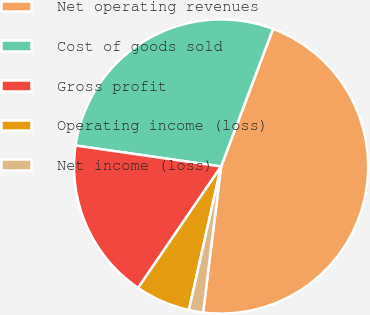<chart> <loc_0><loc_0><loc_500><loc_500><pie_chart><fcel>Net operating revenues<fcel>Cost of goods sold<fcel>Gross profit<fcel>Operating income (loss)<fcel>Net income (loss)<nl><fcel>46.21%<fcel>28.46%<fcel>17.74%<fcel>6.03%<fcel>1.56%<nl></chart> 